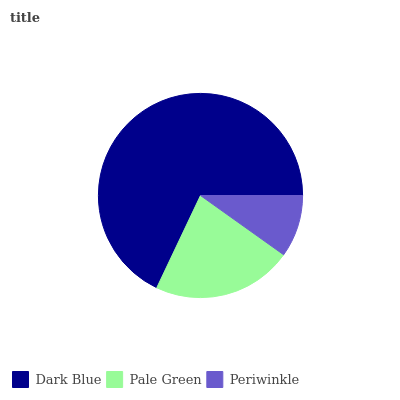Is Periwinkle the minimum?
Answer yes or no. Yes. Is Dark Blue the maximum?
Answer yes or no. Yes. Is Pale Green the minimum?
Answer yes or no. No. Is Pale Green the maximum?
Answer yes or no. No. Is Dark Blue greater than Pale Green?
Answer yes or no. Yes. Is Pale Green less than Dark Blue?
Answer yes or no. Yes. Is Pale Green greater than Dark Blue?
Answer yes or no. No. Is Dark Blue less than Pale Green?
Answer yes or no. No. Is Pale Green the high median?
Answer yes or no. Yes. Is Pale Green the low median?
Answer yes or no. Yes. Is Dark Blue the high median?
Answer yes or no. No. Is Periwinkle the low median?
Answer yes or no. No. 